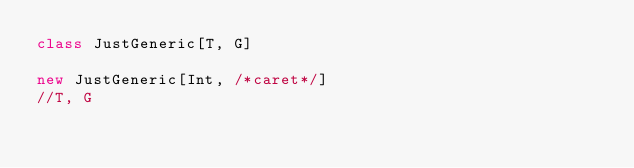<code> <loc_0><loc_0><loc_500><loc_500><_Scala_>class JustGeneric[T, G]

new JustGeneric[Int, /*caret*/]
//T, G</code> 